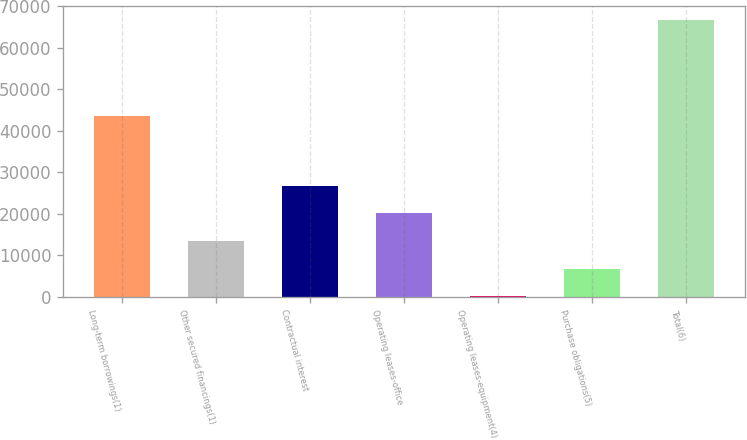Convert chart. <chart><loc_0><loc_0><loc_500><loc_500><bar_chart><fcel>Long-term borrowings(1)<fcel>Other secured financings(1)<fcel>Contractual interest<fcel>Operating leases-office<fcel>Operating leases-equipment(4)<fcel>Purchase obligations(5)<fcel>Total(6)<nl><fcel>43545<fcel>13422.4<fcel>26746.8<fcel>20084.6<fcel>98<fcel>6760.2<fcel>66720<nl></chart> 